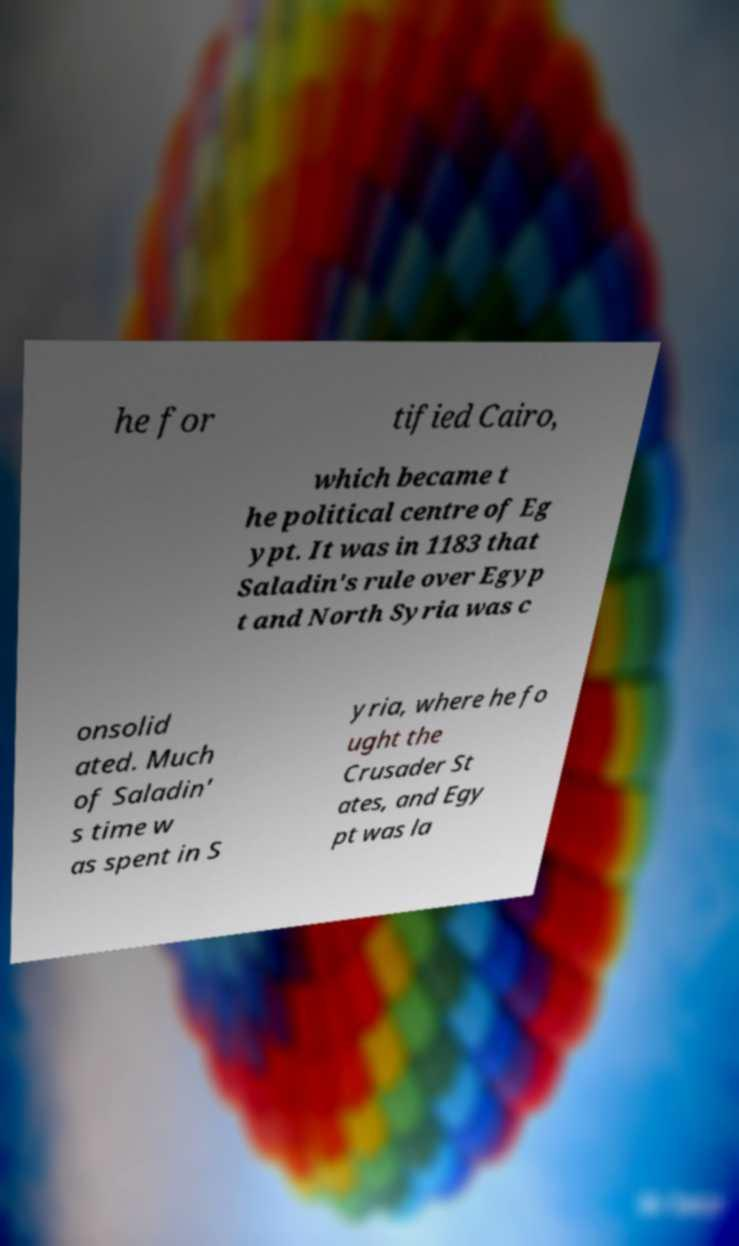Please identify and transcribe the text found in this image. he for tified Cairo, which became t he political centre of Eg ypt. It was in 1183 that Saladin's rule over Egyp t and North Syria was c onsolid ated. Much of Saladin' s time w as spent in S yria, where he fo ught the Crusader St ates, and Egy pt was la 